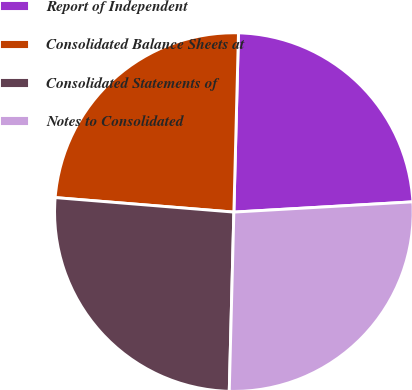Convert chart. <chart><loc_0><loc_0><loc_500><loc_500><pie_chart><fcel>Report of Independent<fcel>Consolidated Balance Sheets at<fcel>Consolidated Statements of<fcel>Notes to Consolidated<nl><fcel>23.68%<fcel>24.12%<fcel>25.88%<fcel>26.32%<nl></chart> 